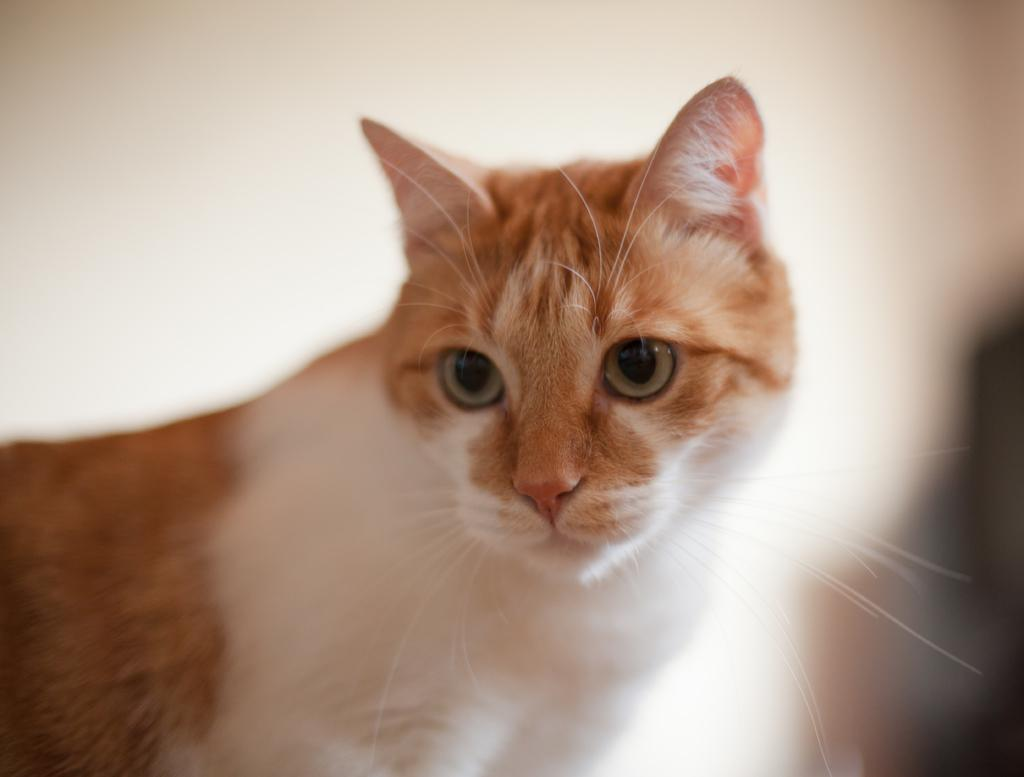What animal is present in the image? There is a cat in the picture. Can you describe the background of the image? The background of the picture is blurry. What flavor of ice cream is the cat enjoying at the seashore in the image? There is no ice cream or seashore present in the image; it features a cat with a blurry background. 